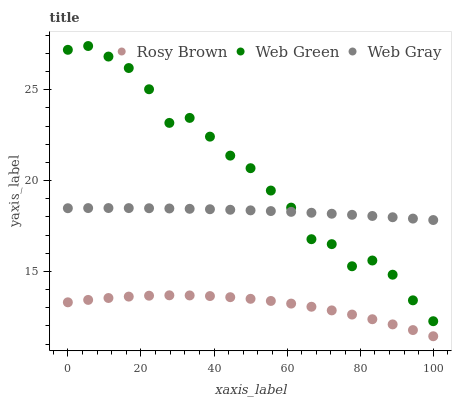Does Rosy Brown have the minimum area under the curve?
Answer yes or no. Yes. Does Web Green have the maximum area under the curve?
Answer yes or no. Yes. Does Web Gray have the minimum area under the curve?
Answer yes or no. No. Does Web Gray have the maximum area under the curve?
Answer yes or no. No. Is Web Gray the smoothest?
Answer yes or no. Yes. Is Web Green the roughest?
Answer yes or no. Yes. Is Web Green the smoothest?
Answer yes or no. No. Is Web Gray the roughest?
Answer yes or no. No. Does Rosy Brown have the lowest value?
Answer yes or no. Yes. Does Web Green have the lowest value?
Answer yes or no. No. Does Web Green have the highest value?
Answer yes or no. Yes. Does Web Gray have the highest value?
Answer yes or no. No. Is Rosy Brown less than Web Gray?
Answer yes or no. Yes. Is Web Gray greater than Rosy Brown?
Answer yes or no. Yes. Does Web Gray intersect Web Green?
Answer yes or no. Yes. Is Web Gray less than Web Green?
Answer yes or no. No. Is Web Gray greater than Web Green?
Answer yes or no. No. Does Rosy Brown intersect Web Gray?
Answer yes or no. No. 